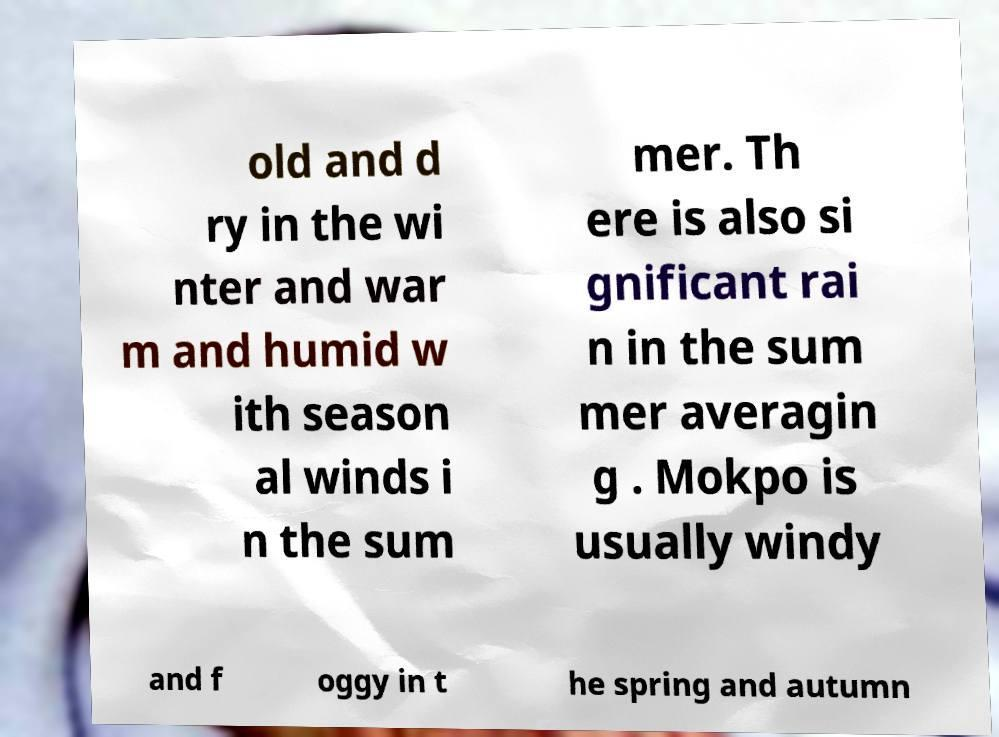What messages or text are displayed in this image? I need them in a readable, typed format. old and d ry in the wi nter and war m and humid w ith season al winds i n the sum mer. Th ere is also si gnificant rai n in the sum mer averagin g . Mokpo is usually windy and f oggy in t he spring and autumn 